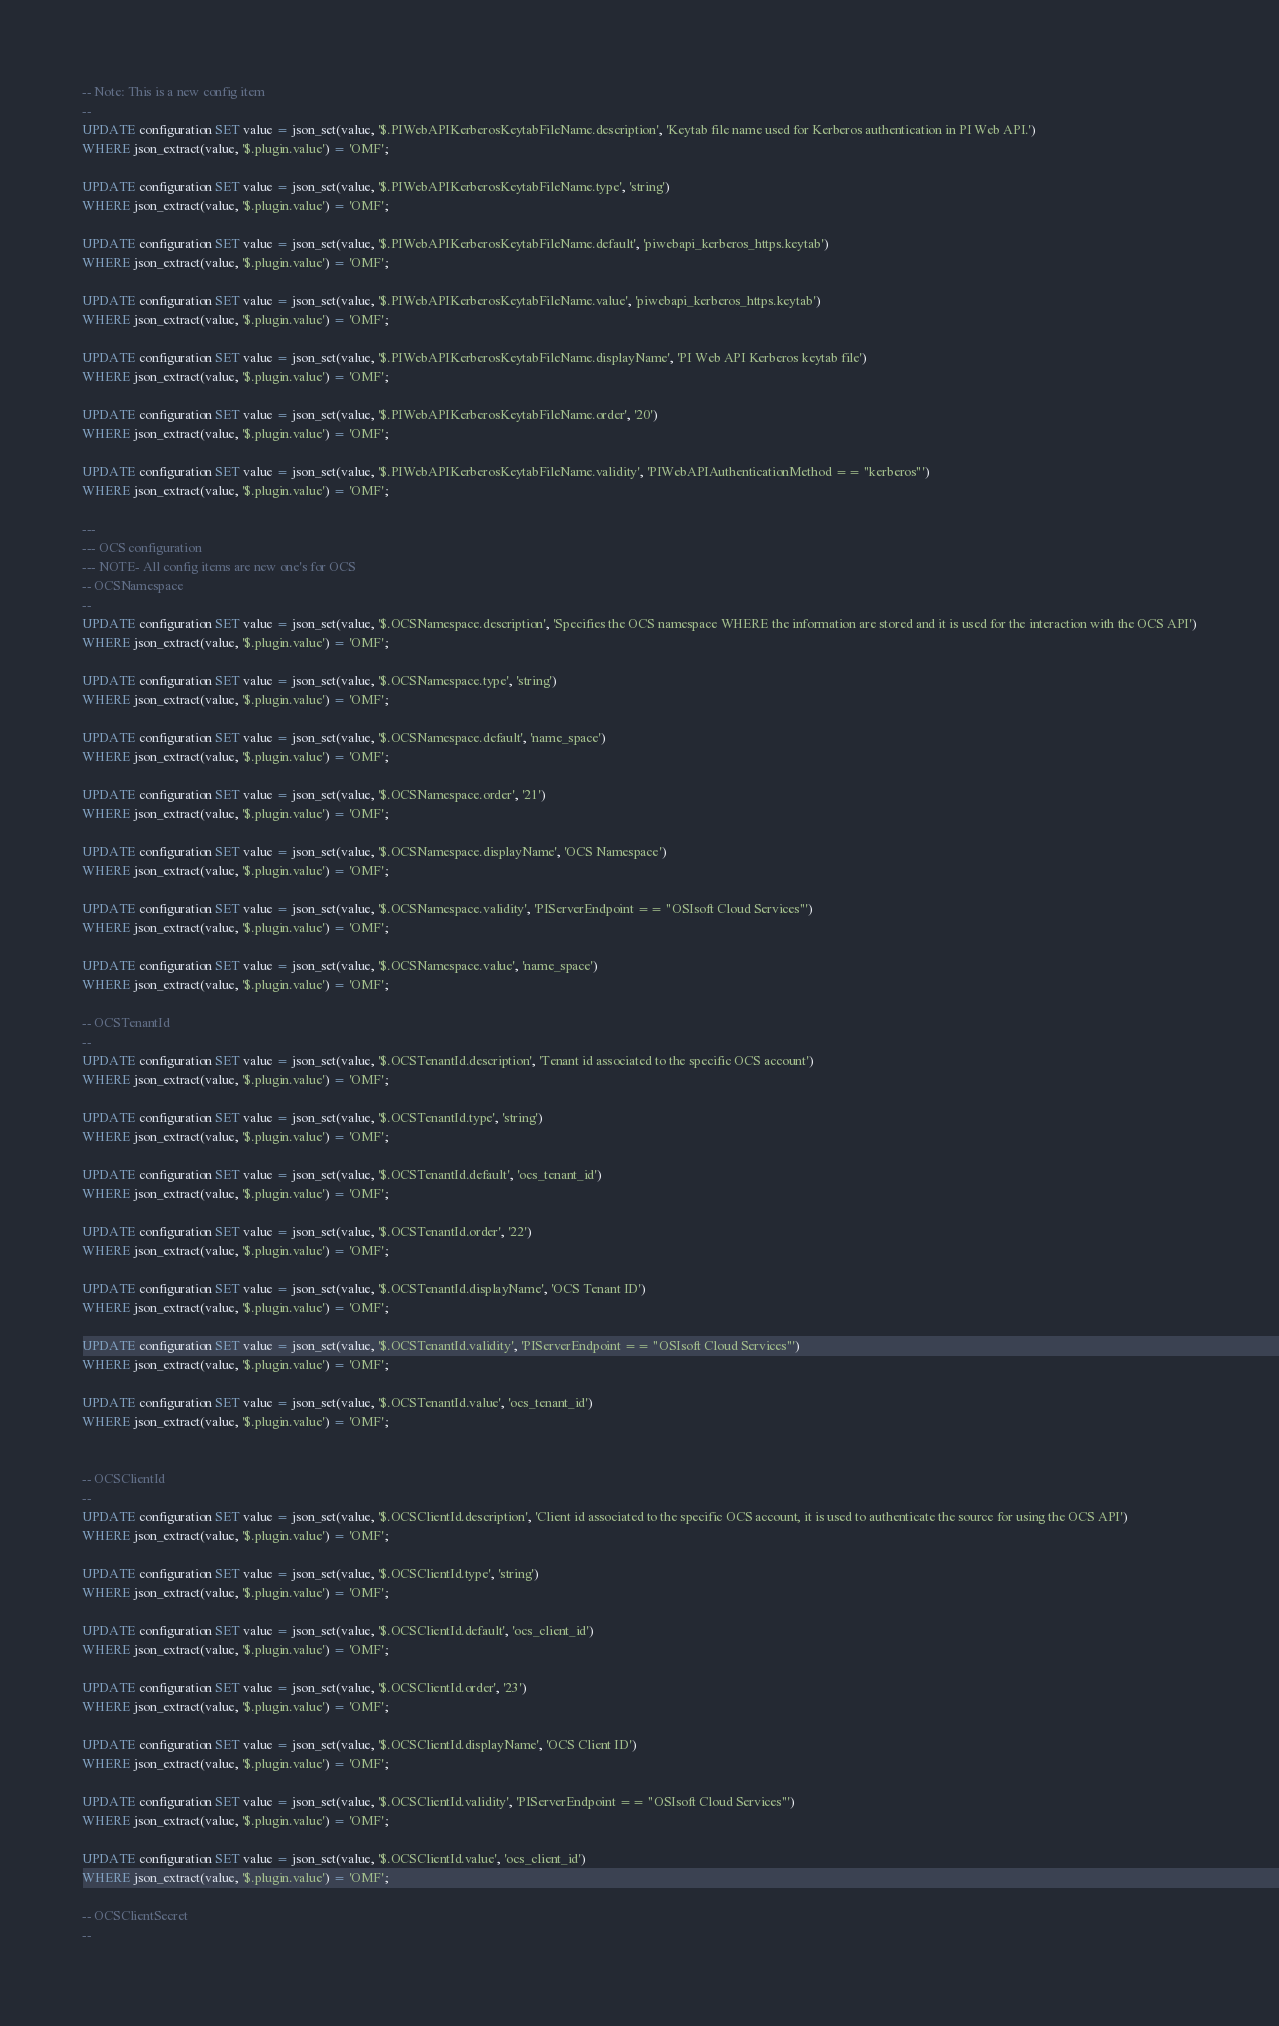<code> <loc_0><loc_0><loc_500><loc_500><_SQL_>-- Note: This is a new config item
--
UPDATE configuration SET value = json_set(value, '$.PIWebAPIKerberosKeytabFileName.description', 'Keytab file name used for Kerberos authentication in PI Web API.')
WHERE json_extract(value, '$.plugin.value') = 'OMF';

UPDATE configuration SET value = json_set(value, '$.PIWebAPIKerberosKeytabFileName.type', 'string')
WHERE json_extract(value, '$.plugin.value') = 'OMF';

UPDATE configuration SET value = json_set(value, '$.PIWebAPIKerberosKeytabFileName.default', 'piwebapi_kerberos_https.keytab')
WHERE json_extract(value, '$.plugin.value') = 'OMF';

UPDATE configuration SET value = json_set(value, '$.PIWebAPIKerberosKeytabFileName.value', 'piwebapi_kerberos_https.keytab')
WHERE json_extract(value, '$.plugin.value') = 'OMF';

UPDATE configuration SET value = json_set(value, '$.PIWebAPIKerberosKeytabFileName.displayName', 'PI Web API Kerberos keytab file')
WHERE json_extract(value, '$.plugin.value') = 'OMF';

UPDATE configuration SET value = json_set(value, '$.PIWebAPIKerberosKeytabFileName.order', '20')
WHERE json_extract(value, '$.plugin.value') = 'OMF';

UPDATE configuration SET value = json_set(value, '$.PIWebAPIKerberosKeytabFileName.validity', 'PIWebAPIAuthenticationMethod == "kerberos"')
WHERE json_extract(value, '$.plugin.value') = 'OMF';

---
--- OCS configuration
--- NOTE- All config items are new one's for OCS
-- OCSNamespace
--
UPDATE configuration SET value = json_set(value, '$.OCSNamespace.description', 'Specifies the OCS namespace WHERE the information are stored and it is used for the interaction with the OCS API')
WHERE json_extract(value, '$.plugin.value') = 'OMF';

UPDATE configuration SET value = json_set(value, '$.OCSNamespace.type', 'string')
WHERE json_extract(value, '$.plugin.value') = 'OMF';

UPDATE configuration SET value = json_set(value, '$.OCSNamespace.default', 'name_space')
WHERE json_extract(value, '$.plugin.value') = 'OMF';

UPDATE configuration SET value = json_set(value, '$.OCSNamespace.order', '21')
WHERE json_extract(value, '$.plugin.value') = 'OMF';

UPDATE configuration SET value = json_set(value, '$.OCSNamespace.displayName', 'OCS Namespace')
WHERE json_extract(value, '$.plugin.value') = 'OMF';

UPDATE configuration SET value = json_set(value, '$.OCSNamespace.validity', 'PIServerEndpoint == "OSIsoft Cloud Services"')
WHERE json_extract(value, '$.plugin.value') = 'OMF';

UPDATE configuration SET value = json_set(value, '$.OCSNamespace.value', 'name_space')
WHERE json_extract(value, '$.plugin.value') = 'OMF';

-- OCSTenantId
--
UPDATE configuration SET value = json_set(value, '$.OCSTenantId.description', 'Tenant id associated to the specific OCS account')
WHERE json_extract(value, '$.plugin.value') = 'OMF';

UPDATE configuration SET value = json_set(value, '$.OCSTenantId.type', 'string')
WHERE json_extract(value, '$.plugin.value') = 'OMF';

UPDATE configuration SET value = json_set(value, '$.OCSTenantId.default', 'ocs_tenant_id')
WHERE json_extract(value, '$.plugin.value') = 'OMF';

UPDATE configuration SET value = json_set(value, '$.OCSTenantId.order', '22')
WHERE json_extract(value, '$.plugin.value') = 'OMF';

UPDATE configuration SET value = json_set(value, '$.OCSTenantId.displayName', 'OCS Tenant ID')
WHERE json_extract(value, '$.plugin.value') = 'OMF';

UPDATE configuration SET value = json_set(value, '$.OCSTenantId.validity', 'PIServerEndpoint == "OSIsoft Cloud Services"')
WHERE json_extract(value, '$.plugin.value') = 'OMF';

UPDATE configuration SET value = json_set(value, '$.OCSTenantId.value', 'ocs_tenant_id')
WHERE json_extract(value, '$.plugin.value') = 'OMF';


-- OCSClientId
--
UPDATE configuration SET value = json_set(value, '$.OCSClientId.description', 'Client id associated to the specific OCS account, it is used to authenticate the source for using the OCS API')
WHERE json_extract(value, '$.plugin.value') = 'OMF';

UPDATE configuration SET value = json_set(value, '$.OCSClientId.type', 'string')
WHERE json_extract(value, '$.plugin.value') = 'OMF';

UPDATE configuration SET value = json_set(value, '$.OCSClientId.default', 'ocs_client_id')
WHERE json_extract(value, '$.plugin.value') = 'OMF';

UPDATE configuration SET value = json_set(value, '$.OCSClientId.order', '23')
WHERE json_extract(value, '$.plugin.value') = 'OMF';

UPDATE configuration SET value = json_set(value, '$.OCSClientId.displayName', 'OCS Client ID')
WHERE json_extract(value, '$.plugin.value') = 'OMF';

UPDATE configuration SET value = json_set(value, '$.OCSClientId.validity', 'PIServerEndpoint == "OSIsoft Cloud Services"')
WHERE json_extract(value, '$.plugin.value') = 'OMF';

UPDATE configuration SET value = json_set(value, '$.OCSClientId.value', 'ocs_client_id')
WHERE json_extract(value, '$.plugin.value') = 'OMF';

-- OCSClientSecret
--</code> 